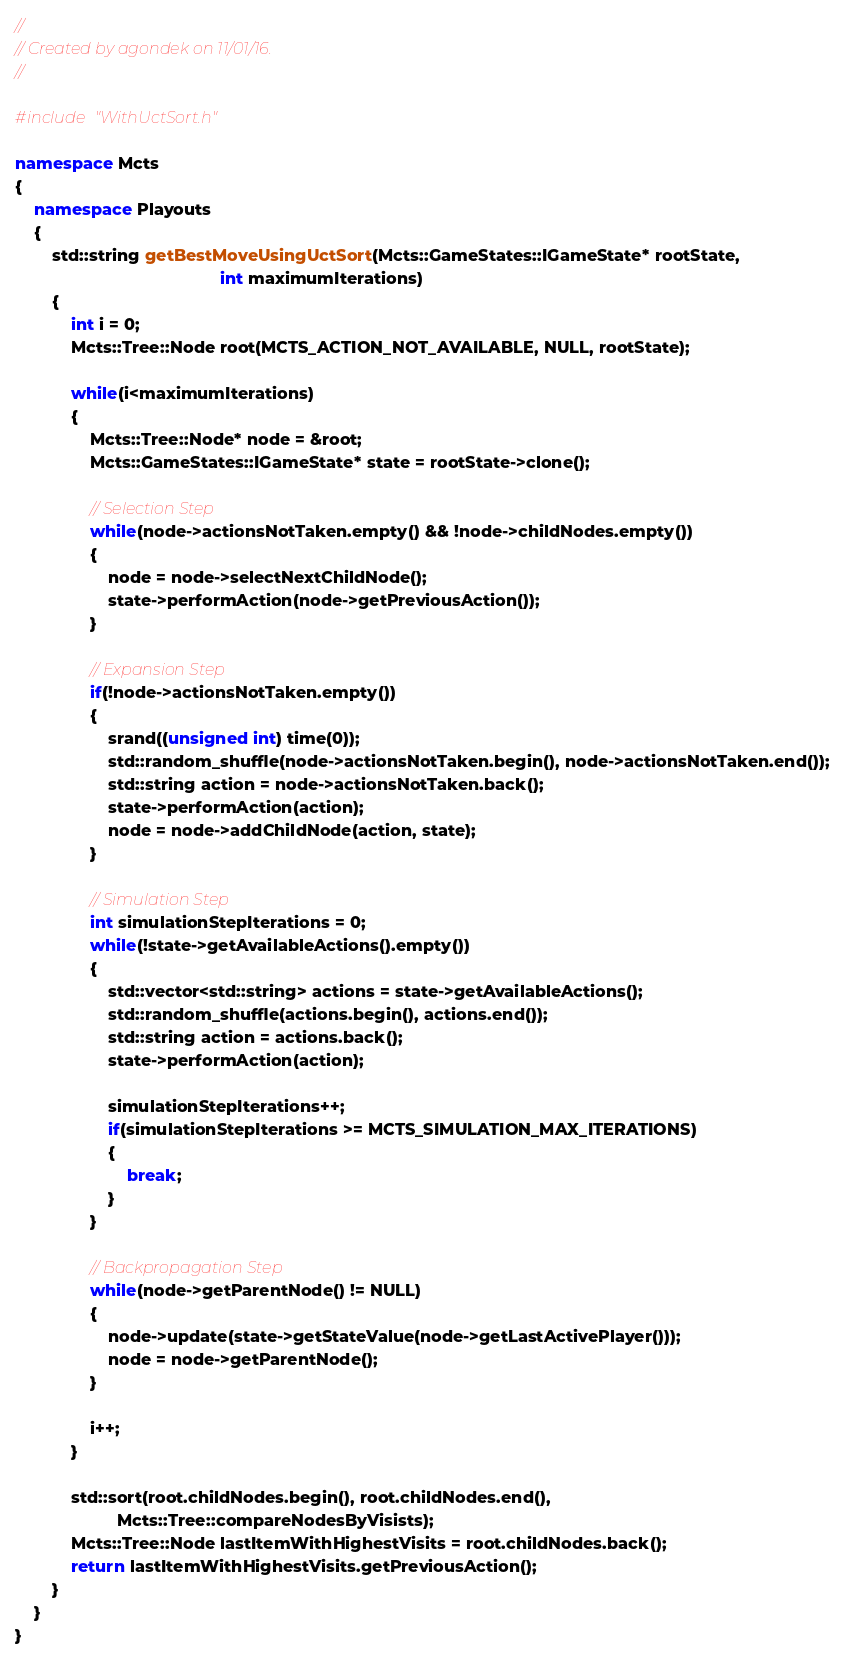Convert code to text. <code><loc_0><loc_0><loc_500><loc_500><_C++_>//
// Created by agondek on 11/01/16.
//

#include "WithUctSort.h"

namespace Mcts
{
    namespace Playouts
    {
        std::string getBestMoveUsingUctSort(Mcts::GameStates::IGameState* rootState,
                                            int maximumIterations)
        {
            int i = 0;
            Mcts::Tree::Node root(MCTS_ACTION_NOT_AVAILABLE, NULL, rootState);

            while(i<maximumIterations)
            {
                Mcts::Tree::Node* node = &root;
                Mcts::GameStates::IGameState* state = rootState->clone();

                // Selection Step
                while(node->actionsNotTaken.empty() && !node->childNodes.empty())
                {
                    node = node->selectNextChildNode();
                    state->performAction(node->getPreviousAction());
                }

                // Expansion Step
                if(!node->actionsNotTaken.empty())
                {
                    srand((unsigned int) time(0));
                    std::random_shuffle(node->actionsNotTaken.begin(), node->actionsNotTaken.end());
                    std::string action = node->actionsNotTaken.back();
                    state->performAction(action);
                    node = node->addChildNode(action, state);
                }

                // Simulation Step
                int simulationStepIterations = 0;
                while(!state->getAvailableActions().empty())
                {
                    std::vector<std::string> actions = state->getAvailableActions();
                    std::random_shuffle(actions.begin(), actions.end());
                    std::string action = actions.back();
                    state->performAction(action);

                    simulationStepIterations++;
                    if(simulationStepIterations >= MCTS_SIMULATION_MAX_ITERATIONS)
                    {
                        break;
                    }
                }

                // Backpropagation Step
                while(node->getParentNode() != NULL)
                {
                    node->update(state->getStateValue(node->getLastActivePlayer()));
                    node = node->getParentNode();
                }

                i++;
            }

            std::sort(root.childNodes.begin(), root.childNodes.end(),
                      Mcts::Tree::compareNodesByVisists);
            Mcts::Tree::Node lastItemWithHighestVisits = root.childNodes.back();
            return lastItemWithHighestVisits.getPreviousAction();
        }
    }
}</code> 